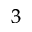<formula> <loc_0><loc_0><loc_500><loc_500>^ { 3 }</formula> 